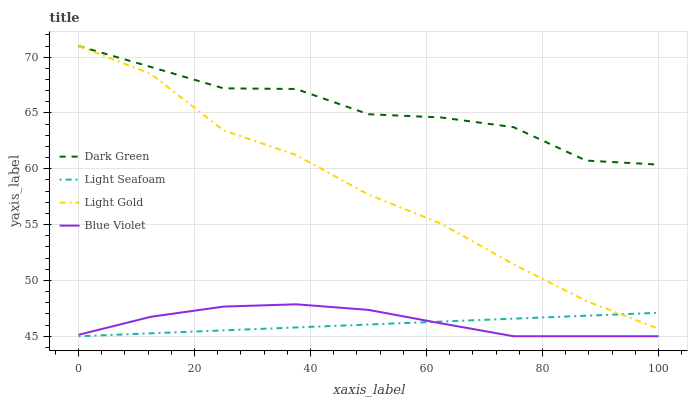Does Light Seafoam have the minimum area under the curve?
Answer yes or no. Yes. Does Dark Green have the maximum area under the curve?
Answer yes or no. Yes. Does Light Gold have the minimum area under the curve?
Answer yes or no. No. Does Light Gold have the maximum area under the curve?
Answer yes or no. No. Is Light Seafoam the smoothest?
Answer yes or no. Yes. Is Dark Green the roughest?
Answer yes or no. Yes. Is Light Gold the smoothest?
Answer yes or no. No. Is Light Gold the roughest?
Answer yes or no. No. Does Light Gold have the lowest value?
Answer yes or no. No. Does Blue Violet have the highest value?
Answer yes or no. No. Is Blue Violet less than Light Gold?
Answer yes or no. Yes. Is Dark Green greater than Light Seafoam?
Answer yes or no. Yes. Does Blue Violet intersect Light Gold?
Answer yes or no. No. 